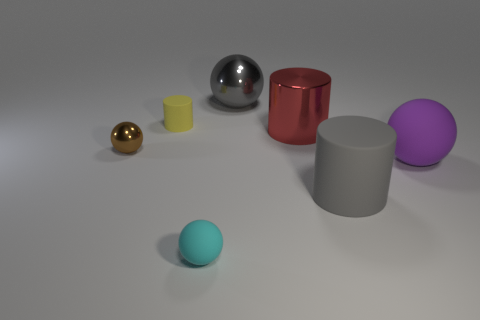Add 2 large cyan metallic balls. How many objects exist? 9 Subtract all balls. How many objects are left? 3 Add 4 big red things. How many big red things are left? 5 Add 4 brown rubber cylinders. How many brown rubber cylinders exist? 4 Subtract 0 blue balls. How many objects are left? 7 Subtract all tiny brown metallic spheres. Subtract all purple spheres. How many objects are left? 5 